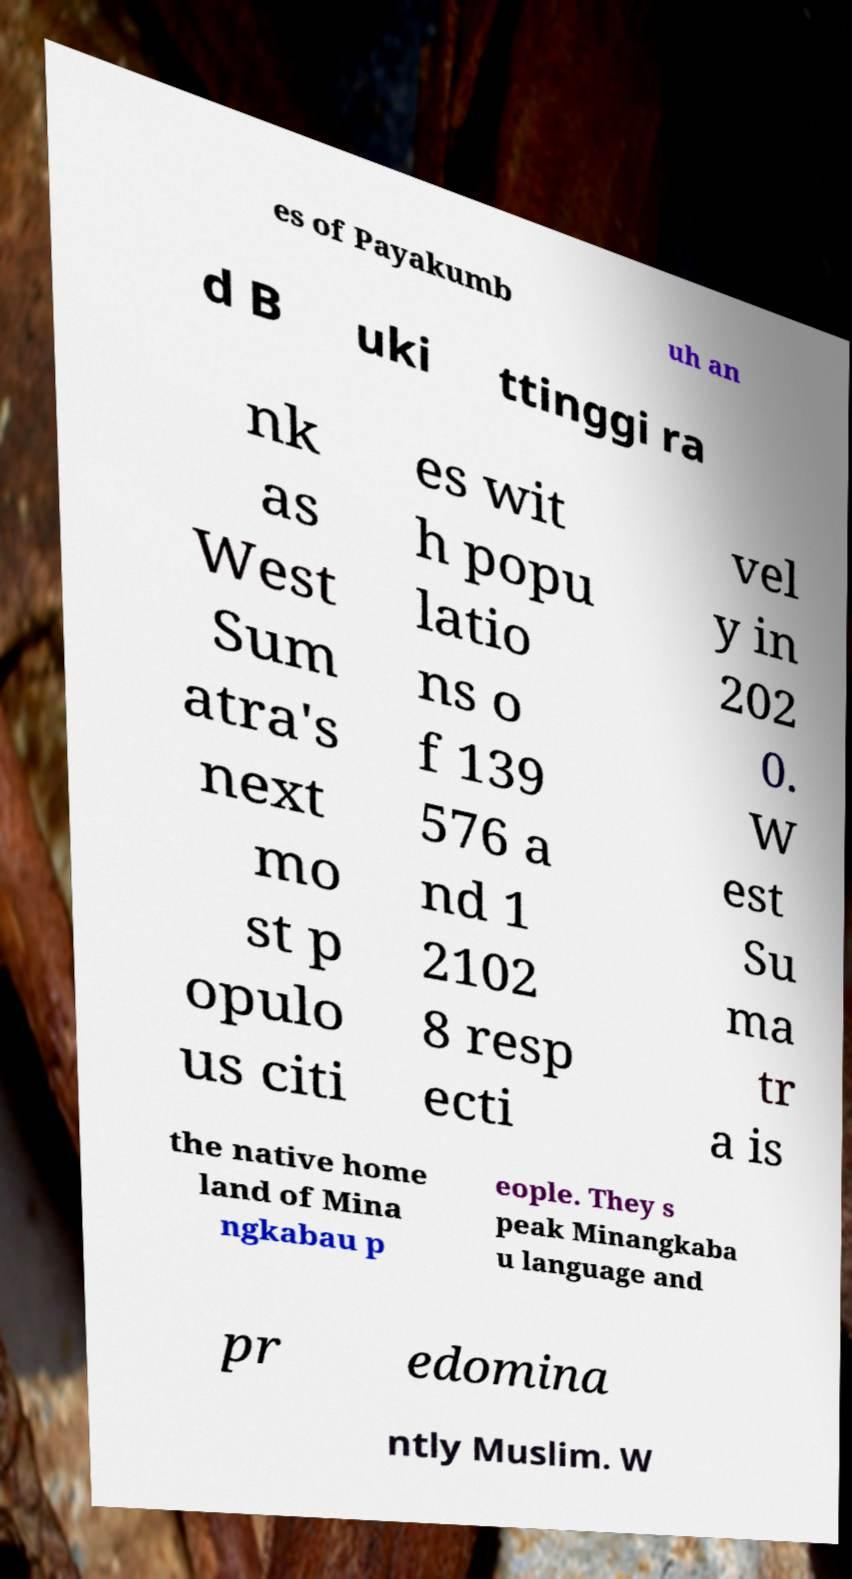Could you extract and type out the text from this image? es of Payakumb uh an d B uki ttinggi ra nk as West Sum atra's next mo st p opulo us citi es wit h popu latio ns o f 139 576 a nd 1 2102 8 resp ecti vel y in 202 0. W est Su ma tr a is the native home land of Mina ngkabau p eople. They s peak Minangkaba u language and pr edomina ntly Muslim. W 